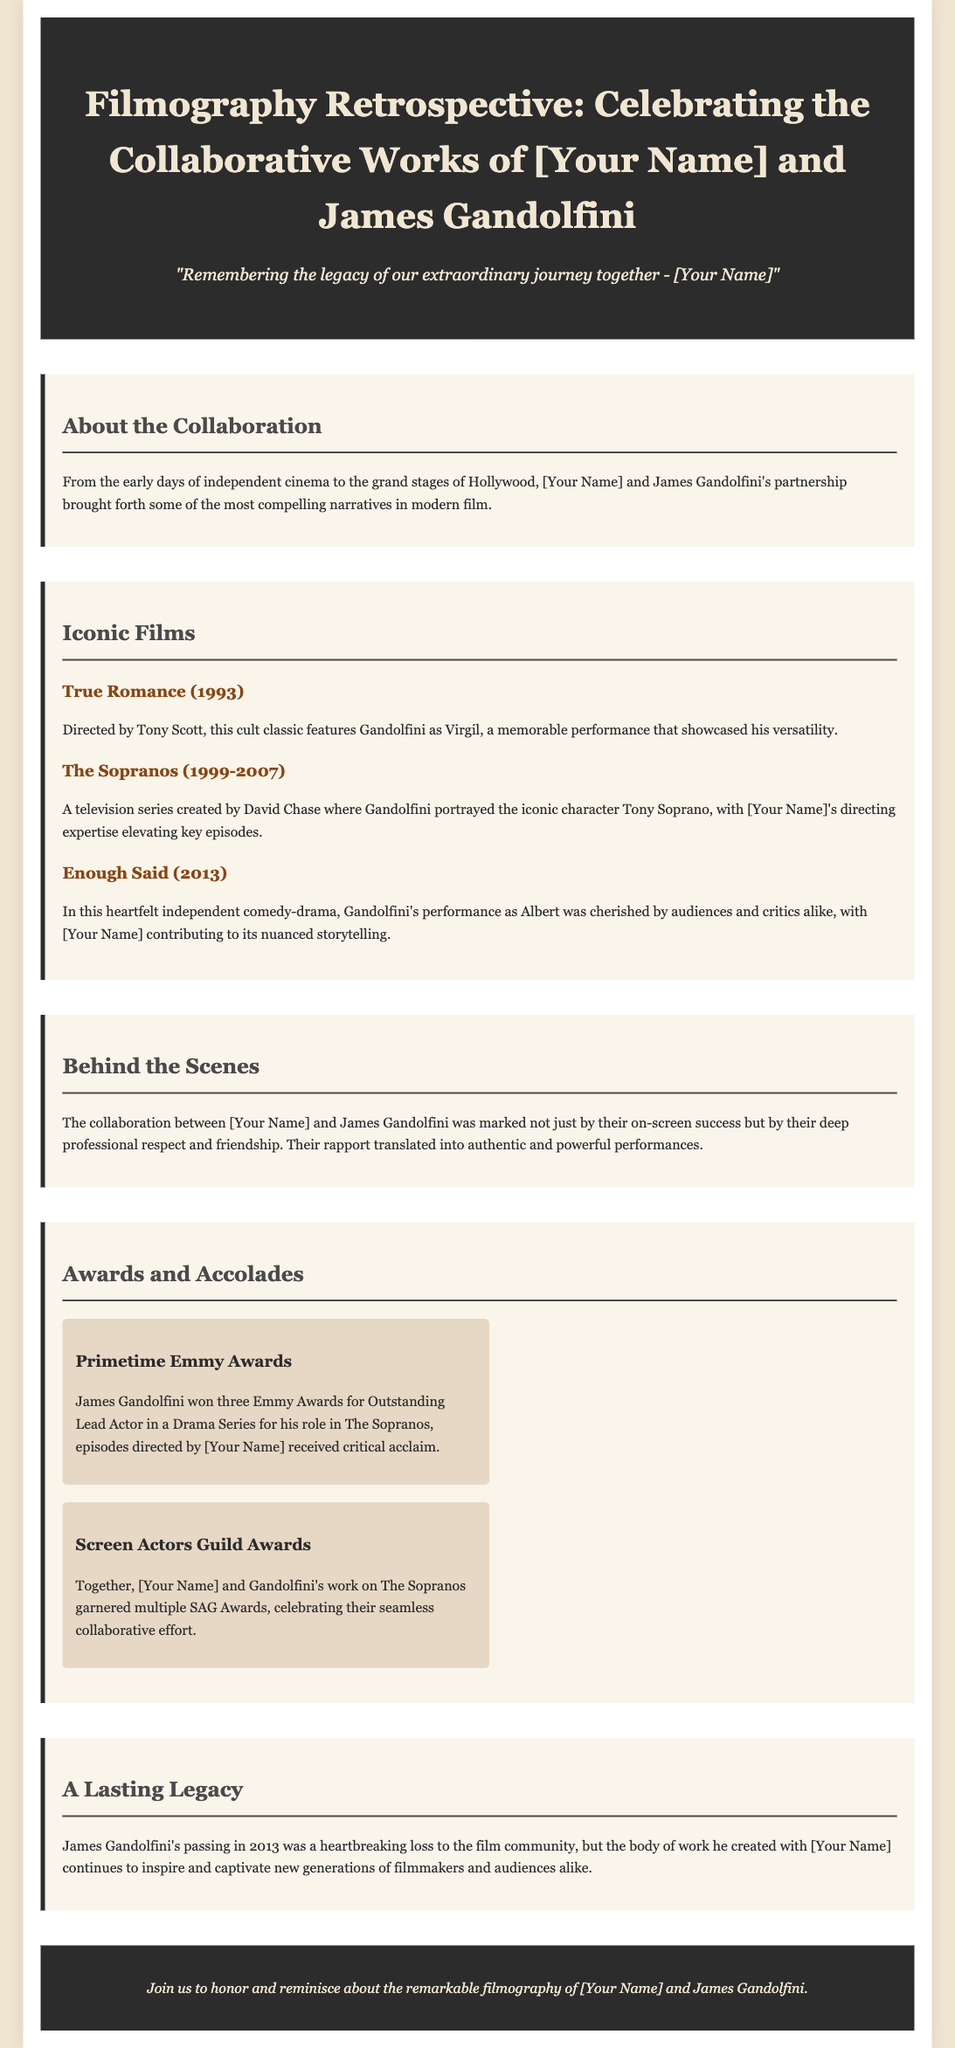What is the title of the retrospective? The title of the retrospective as seen in the header is "Filmography Retrospective: Celebrating the Collaborative Works of [Your Name] and James Gandolfini".
Answer: Filmography Retrospective: Celebrating the Collaborative Works What year was "True Romance" released? The release year for "True Romance" is stated in the document under the filmography section.
Answer: 1993 Who created "The Sopranos"? The creator of "The Sopranos" is mentioned in the description of the series in the document.
Answer: David Chase What is one award James Gandolfini won? The document lists specific awards Gandolfini won, specifically under the Awards and Accolades section.
Answer: Primetime Emmy Awards What was James Gandolfini's iconic character in "The Sopranos"? The character he portrayed is mentioned alongside the series title in the document.
Answer: Tony Soprano What genre is "Enough Said"? The genre of the film "Enough Said" can be inferred from the description provided in the filmography section.
Answer: Independent comedy-drama How many Emmy Awards did Gandolfini win for "The Sopranos"? The document states that he won three Emmy Awards, which is noted under the Awards and Accolades section.
Answer: Three What is mentioned as a lasting impact of Gandolfini's work? The document discusses the influence of Gandolfini's collaborative work with the director after his passing.
Answer: Inspire and captivate new generations What do the awards mentioned celebrate? The awards noted underline the collaborative efforts between the director and Gandolfini in their projects.
Answer: Seamless collaborative effort 